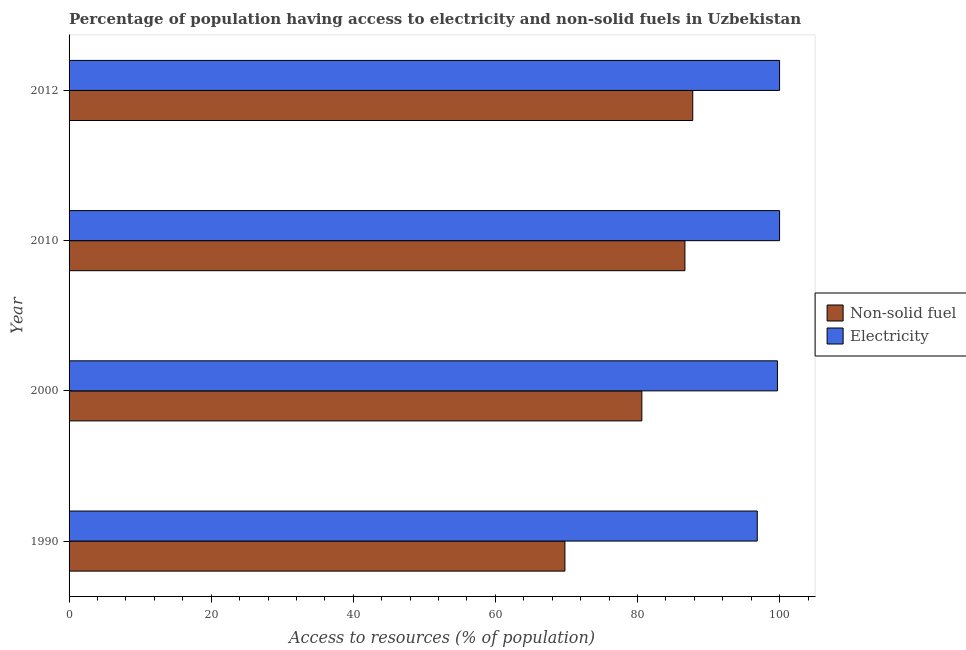Are the number of bars on each tick of the Y-axis equal?
Ensure brevity in your answer.  Yes. How many bars are there on the 2nd tick from the top?
Offer a very short reply. 2. How many bars are there on the 4th tick from the bottom?
Give a very brief answer. 2. What is the label of the 2nd group of bars from the top?
Offer a terse response. 2010. What is the percentage of population having access to electricity in 1990?
Provide a succinct answer. 96.86. Across all years, what is the maximum percentage of population having access to non-solid fuel?
Provide a short and direct response. 87.78. Across all years, what is the minimum percentage of population having access to non-solid fuel?
Offer a very short reply. 69.79. In which year was the percentage of population having access to electricity maximum?
Provide a short and direct response. 2010. What is the total percentage of population having access to non-solid fuel in the graph?
Offer a very short reply. 324.86. What is the difference between the percentage of population having access to non-solid fuel in 2010 and that in 2012?
Keep it short and to the point. -1.1. What is the difference between the percentage of population having access to non-solid fuel in 2000 and the percentage of population having access to electricity in 2010?
Ensure brevity in your answer.  -19.38. What is the average percentage of population having access to electricity per year?
Your response must be concise. 99.14. In the year 2010, what is the difference between the percentage of population having access to electricity and percentage of population having access to non-solid fuel?
Make the answer very short. 13.32. What is the ratio of the percentage of population having access to non-solid fuel in 1990 to that in 2010?
Provide a succinct answer. 0.81. Is the percentage of population having access to non-solid fuel in 1990 less than that in 2000?
Offer a terse response. Yes. Is the difference between the percentage of population having access to non-solid fuel in 1990 and 2012 greater than the difference between the percentage of population having access to electricity in 1990 and 2012?
Provide a short and direct response. No. What is the difference between the highest and the lowest percentage of population having access to non-solid fuel?
Keep it short and to the point. 17.99. In how many years, is the percentage of population having access to non-solid fuel greater than the average percentage of population having access to non-solid fuel taken over all years?
Your answer should be very brief. 2. What does the 1st bar from the top in 2010 represents?
Provide a succinct answer. Electricity. What does the 2nd bar from the bottom in 2010 represents?
Give a very brief answer. Electricity. Are the values on the major ticks of X-axis written in scientific E-notation?
Offer a terse response. No. Does the graph contain any zero values?
Offer a very short reply. No. Does the graph contain grids?
Your response must be concise. No. Where does the legend appear in the graph?
Offer a terse response. Center right. How many legend labels are there?
Your response must be concise. 2. How are the legend labels stacked?
Make the answer very short. Vertical. What is the title of the graph?
Your response must be concise. Percentage of population having access to electricity and non-solid fuels in Uzbekistan. Does "Quasi money growth" appear as one of the legend labels in the graph?
Ensure brevity in your answer.  No. What is the label or title of the X-axis?
Your answer should be very brief. Access to resources (% of population). What is the label or title of the Y-axis?
Offer a terse response. Year. What is the Access to resources (% of population) of Non-solid fuel in 1990?
Offer a very short reply. 69.79. What is the Access to resources (% of population) of Electricity in 1990?
Offer a terse response. 96.86. What is the Access to resources (% of population) in Non-solid fuel in 2000?
Your response must be concise. 80.62. What is the Access to resources (% of population) in Electricity in 2000?
Ensure brevity in your answer.  99.7. What is the Access to resources (% of population) in Non-solid fuel in 2010?
Provide a short and direct response. 86.68. What is the Access to resources (% of population) of Non-solid fuel in 2012?
Your answer should be compact. 87.78. Across all years, what is the maximum Access to resources (% of population) in Non-solid fuel?
Your response must be concise. 87.78. Across all years, what is the minimum Access to resources (% of population) of Non-solid fuel?
Your answer should be compact. 69.79. Across all years, what is the minimum Access to resources (% of population) in Electricity?
Keep it short and to the point. 96.86. What is the total Access to resources (% of population) of Non-solid fuel in the graph?
Give a very brief answer. 324.86. What is the total Access to resources (% of population) of Electricity in the graph?
Make the answer very short. 396.56. What is the difference between the Access to resources (% of population) of Non-solid fuel in 1990 and that in 2000?
Your answer should be very brief. -10.83. What is the difference between the Access to resources (% of population) in Electricity in 1990 and that in 2000?
Your response must be concise. -2.84. What is the difference between the Access to resources (% of population) in Non-solid fuel in 1990 and that in 2010?
Offer a terse response. -16.89. What is the difference between the Access to resources (% of population) in Electricity in 1990 and that in 2010?
Provide a succinct answer. -3.14. What is the difference between the Access to resources (% of population) of Non-solid fuel in 1990 and that in 2012?
Make the answer very short. -17.99. What is the difference between the Access to resources (% of population) of Electricity in 1990 and that in 2012?
Offer a very short reply. -3.14. What is the difference between the Access to resources (% of population) of Non-solid fuel in 2000 and that in 2010?
Your answer should be compact. -6.06. What is the difference between the Access to resources (% of population) of Electricity in 2000 and that in 2010?
Make the answer very short. -0.3. What is the difference between the Access to resources (% of population) in Non-solid fuel in 2000 and that in 2012?
Make the answer very short. -7.16. What is the difference between the Access to resources (% of population) in Electricity in 2000 and that in 2012?
Provide a short and direct response. -0.3. What is the difference between the Access to resources (% of population) of Non-solid fuel in 2010 and that in 2012?
Offer a terse response. -1.1. What is the difference between the Access to resources (% of population) of Non-solid fuel in 1990 and the Access to resources (% of population) of Electricity in 2000?
Keep it short and to the point. -29.91. What is the difference between the Access to resources (% of population) of Non-solid fuel in 1990 and the Access to resources (% of population) of Electricity in 2010?
Make the answer very short. -30.21. What is the difference between the Access to resources (% of population) of Non-solid fuel in 1990 and the Access to resources (% of population) of Electricity in 2012?
Keep it short and to the point. -30.21. What is the difference between the Access to resources (% of population) in Non-solid fuel in 2000 and the Access to resources (% of population) in Electricity in 2010?
Offer a terse response. -19.38. What is the difference between the Access to resources (% of population) in Non-solid fuel in 2000 and the Access to resources (% of population) in Electricity in 2012?
Offer a very short reply. -19.38. What is the difference between the Access to resources (% of population) in Non-solid fuel in 2010 and the Access to resources (% of population) in Electricity in 2012?
Provide a short and direct response. -13.32. What is the average Access to resources (% of population) in Non-solid fuel per year?
Offer a terse response. 81.22. What is the average Access to resources (% of population) in Electricity per year?
Your response must be concise. 99.14. In the year 1990, what is the difference between the Access to resources (% of population) of Non-solid fuel and Access to resources (% of population) of Electricity?
Offer a very short reply. -27.07. In the year 2000, what is the difference between the Access to resources (% of population) of Non-solid fuel and Access to resources (% of population) of Electricity?
Make the answer very short. -19.08. In the year 2010, what is the difference between the Access to resources (% of population) of Non-solid fuel and Access to resources (% of population) of Electricity?
Your response must be concise. -13.32. In the year 2012, what is the difference between the Access to resources (% of population) of Non-solid fuel and Access to resources (% of population) of Electricity?
Offer a very short reply. -12.22. What is the ratio of the Access to resources (% of population) in Non-solid fuel in 1990 to that in 2000?
Offer a terse response. 0.87. What is the ratio of the Access to resources (% of population) of Electricity in 1990 to that in 2000?
Your answer should be very brief. 0.97. What is the ratio of the Access to resources (% of population) of Non-solid fuel in 1990 to that in 2010?
Offer a terse response. 0.81. What is the ratio of the Access to resources (% of population) in Electricity in 1990 to that in 2010?
Offer a very short reply. 0.97. What is the ratio of the Access to resources (% of population) in Non-solid fuel in 1990 to that in 2012?
Your response must be concise. 0.8. What is the ratio of the Access to resources (% of population) in Electricity in 1990 to that in 2012?
Your answer should be compact. 0.97. What is the ratio of the Access to resources (% of population) in Non-solid fuel in 2000 to that in 2010?
Provide a succinct answer. 0.93. What is the ratio of the Access to resources (% of population) in Electricity in 2000 to that in 2010?
Keep it short and to the point. 1. What is the ratio of the Access to resources (% of population) of Non-solid fuel in 2000 to that in 2012?
Provide a succinct answer. 0.92. What is the ratio of the Access to resources (% of population) in Electricity in 2000 to that in 2012?
Your answer should be very brief. 1. What is the ratio of the Access to resources (% of population) of Non-solid fuel in 2010 to that in 2012?
Keep it short and to the point. 0.99. What is the difference between the highest and the second highest Access to resources (% of population) of Non-solid fuel?
Provide a short and direct response. 1.1. What is the difference between the highest and the second highest Access to resources (% of population) of Electricity?
Provide a short and direct response. 0. What is the difference between the highest and the lowest Access to resources (% of population) of Non-solid fuel?
Give a very brief answer. 17.99. What is the difference between the highest and the lowest Access to resources (% of population) in Electricity?
Your answer should be compact. 3.14. 